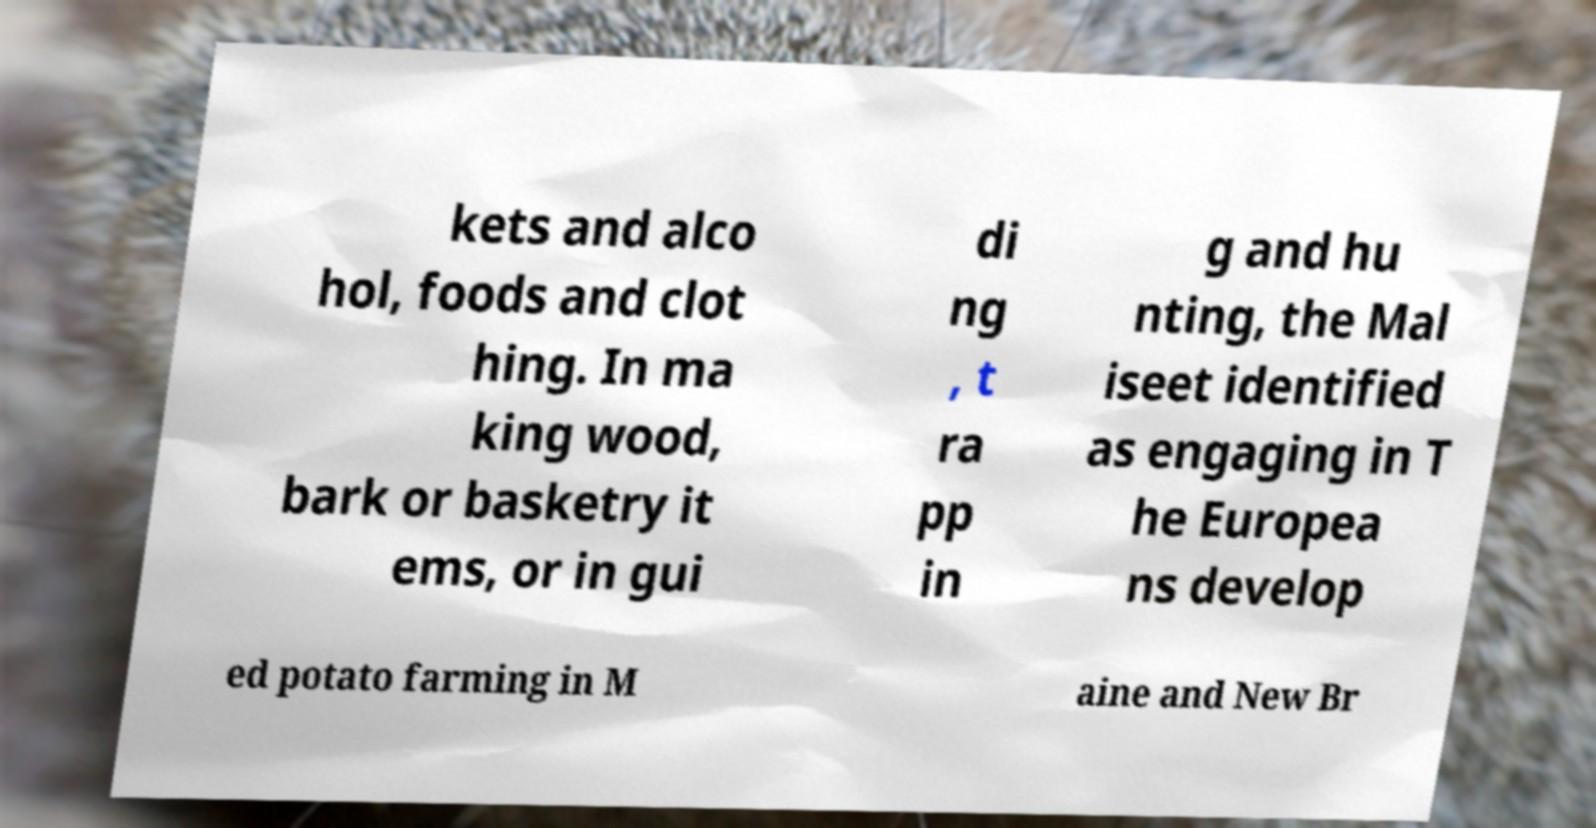Could you extract and type out the text from this image? kets and alco hol, foods and clot hing. In ma king wood, bark or basketry it ems, or in gui di ng , t ra pp in g and hu nting, the Mal iseet identified as engaging in T he Europea ns develop ed potato farming in M aine and New Br 